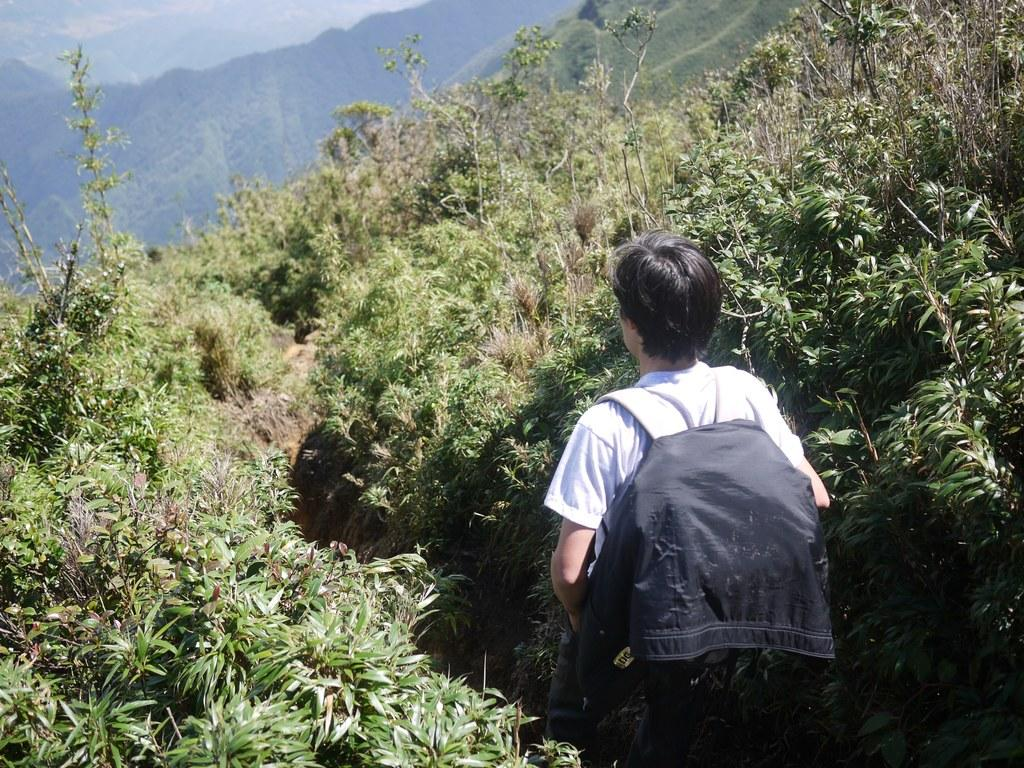What is the person in the image carrying? The person in the image is carrying a bag. What is inside the bag? The bag contains cloth. What can be seen in the image besides the person and the bag? There are plants in the image. What is visible in the background of the image? There are hills visible in the background of the image. Can you see an argument taking place between the plants in the image? There is no argument taking place in the image; it only shows a person carrying a bag with cloth, plants, and hills in the background. 